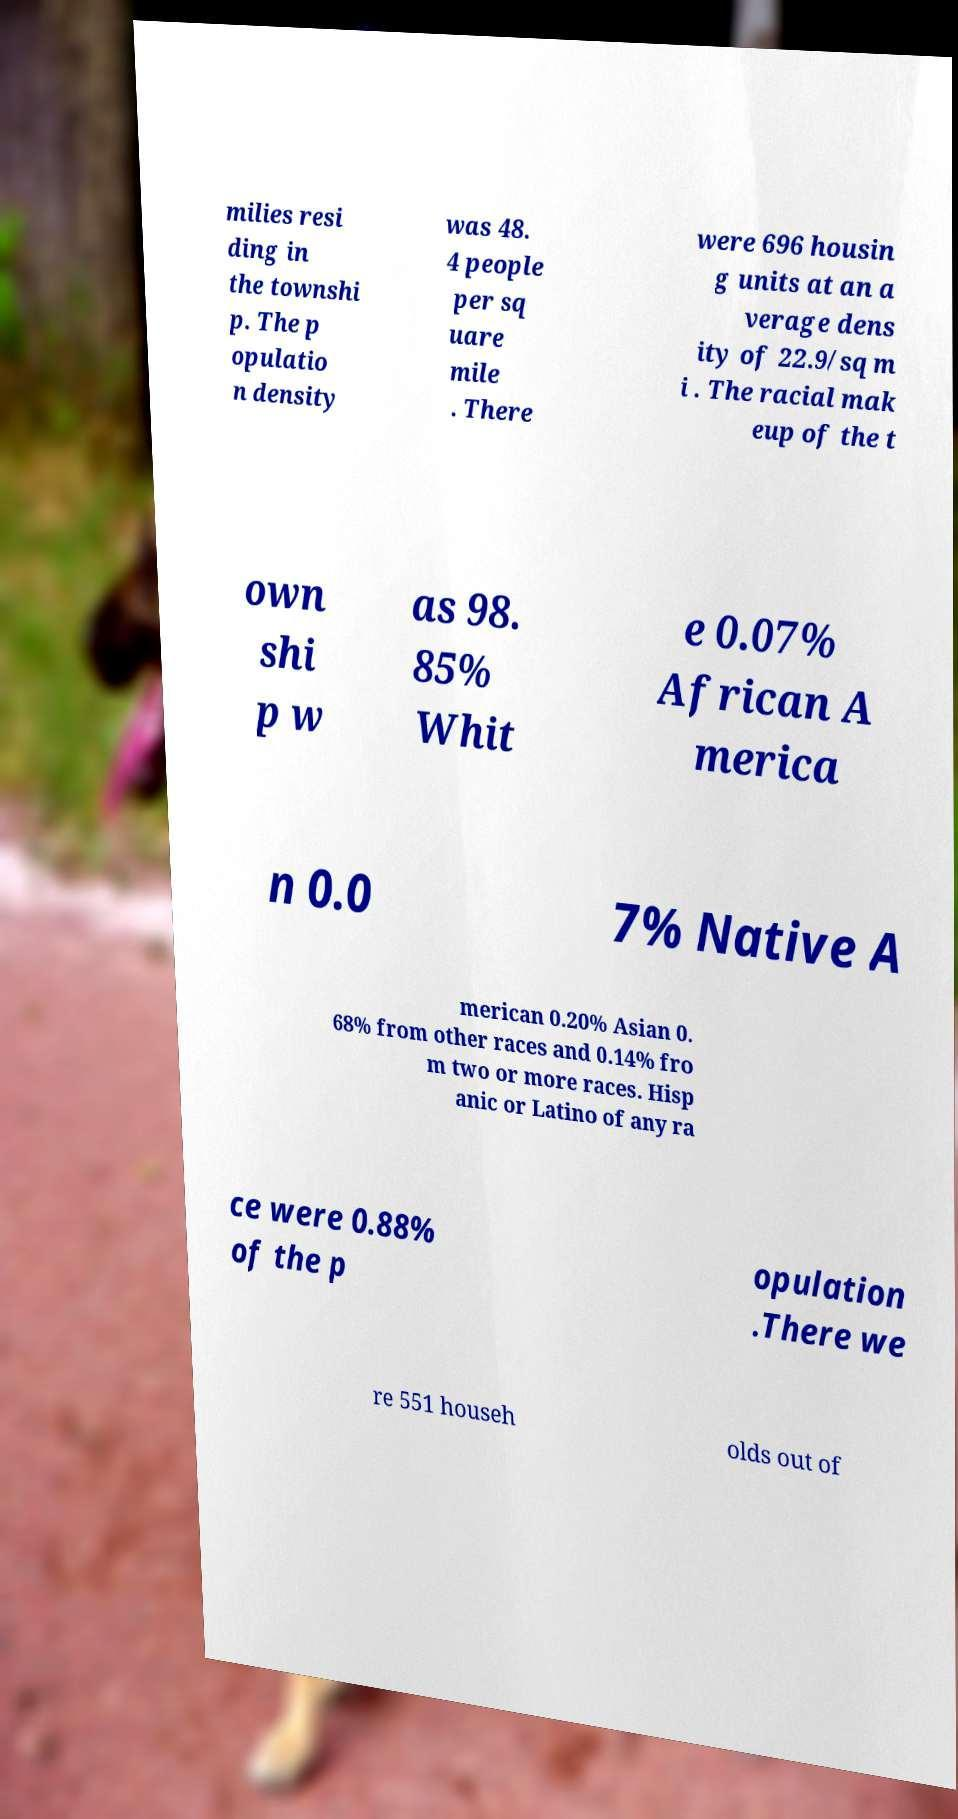There's text embedded in this image that I need extracted. Can you transcribe it verbatim? milies resi ding in the townshi p. The p opulatio n density was 48. 4 people per sq uare mile . There were 696 housin g units at an a verage dens ity of 22.9/sq m i . The racial mak eup of the t own shi p w as 98. 85% Whit e 0.07% African A merica n 0.0 7% Native A merican 0.20% Asian 0. 68% from other races and 0.14% fro m two or more races. Hisp anic or Latino of any ra ce were 0.88% of the p opulation .There we re 551 househ olds out of 